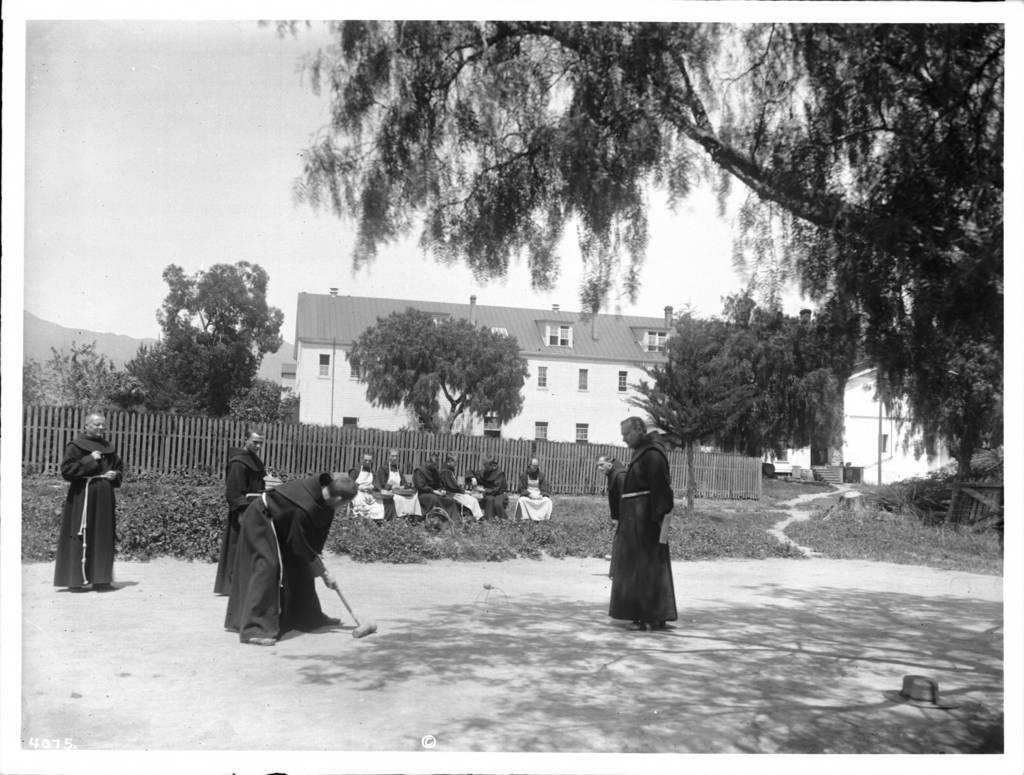Can you describe this image briefly? In this picture I can observe four people standing on the land. Some of them are sitting on the land in the middle of the picture. Behind them there is a wooden railing. In the background there are trees, building and sky. 